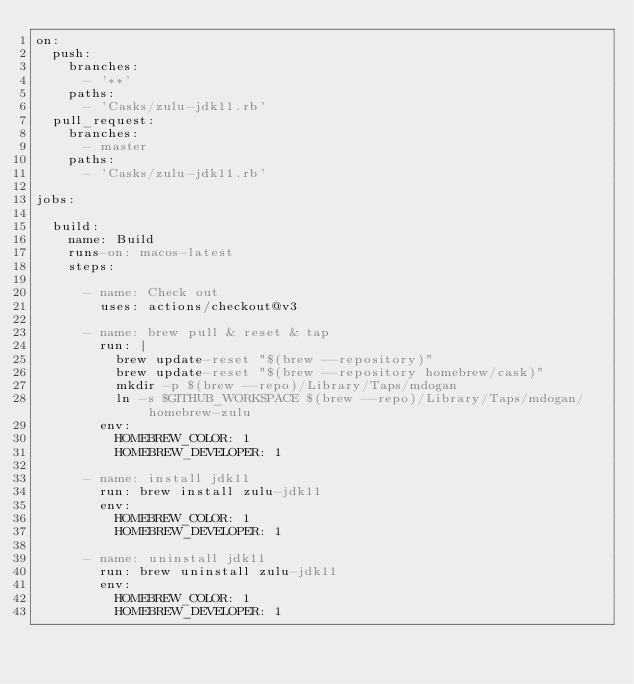<code> <loc_0><loc_0><loc_500><loc_500><_YAML_>on:
  push:
    branches:
      - '**'
    paths:
      - 'Casks/zulu-jdk11.rb'
  pull_request:
    branches:
      - master
    paths:
      - 'Casks/zulu-jdk11.rb'

jobs:

  build:
    name: Build
    runs-on: macos-latest
    steps:

      - name: Check out
        uses: actions/checkout@v3

      - name: brew pull & reset & tap
        run: |
          brew update-reset "$(brew --repository)"
          brew update-reset "$(brew --repository homebrew/cask)"
          mkdir -p $(brew --repo)/Library/Taps/mdogan
          ln -s $GITHUB_WORKSPACE $(brew --repo)/Library/Taps/mdogan/homebrew-zulu
        env:
          HOMEBREW_COLOR: 1
          HOMEBREW_DEVELOPER: 1

      - name: install jdk11
        run: brew install zulu-jdk11
        env:
          HOMEBREW_COLOR: 1
          HOMEBREW_DEVELOPER: 1

      - name: uninstall jdk11
        run: brew uninstall zulu-jdk11
        env:
          HOMEBREW_COLOR: 1
          HOMEBREW_DEVELOPER: 1
</code> 